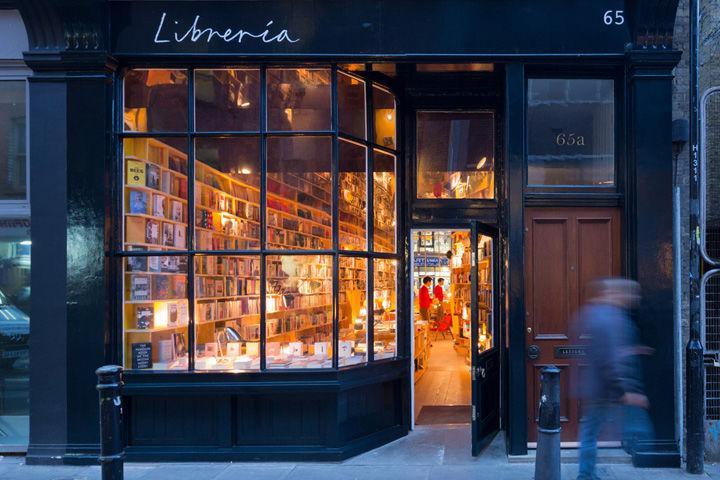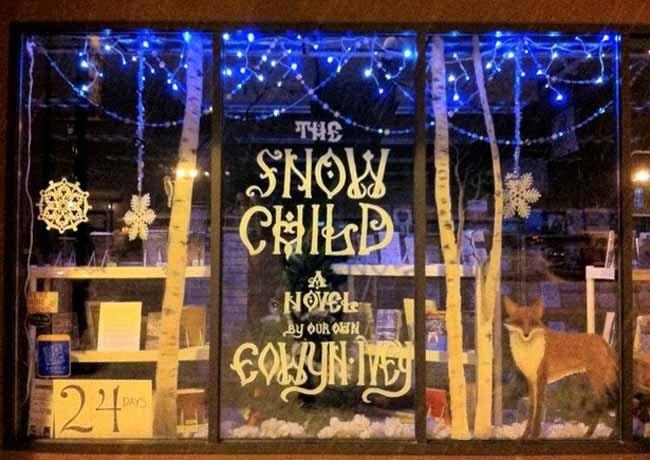The first image is the image on the left, the second image is the image on the right. Assess this claim about the two images: "One of the images features a light blue storefront that has a moon on display.". Correct or not? Answer yes or no. No. 